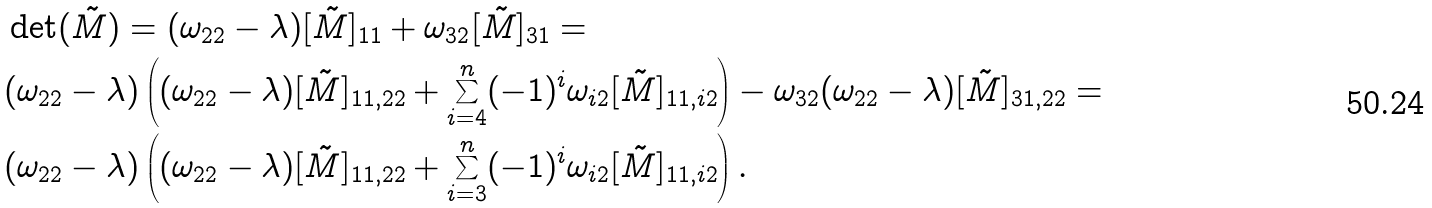Convert formula to latex. <formula><loc_0><loc_0><loc_500><loc_500>& \det ( \tilde { M } ) = ( \omega _ { 2 2 } - \lambda ) [ \tilde { M } ] _ { 1 1 } + \omega _ { 3 2 } [ \tilde { M } ] _ { 3 1 } = \\ & ( \omega _ { 2 2 } - \lambda ) \left ( ( \omega _ { 2 2 } - \lambda ) [ \tilde { M } ] _ { 1 1 , 2 2 } + \sum _ { i = 4 } ^ { n } ( - 1 ) ^ { i } \omega _ { i 2 } [ \tilde { M } ] _ { 1 1 , i 2 } \right ) - \omega _ { 3 2 } ( \omega _ { 2 2 } - \lambda ) [ \tilde { M } ] _ { 3 1 , 2 2 } = \\ & ( \omega _ { 2 2 } - \lambda ) \left ( ( \omega _ { 2 2 } - \lambda ) [ \tilde { M } ] _ { 1 1 , 2 2 } + \sum _ { i = 3 } ^ { n } ( - 1 ) ^ { i } \omega _ { i 2 } [ \tilde { M } ] _ { 1 1 , i 2 } \right ) .</formula> 